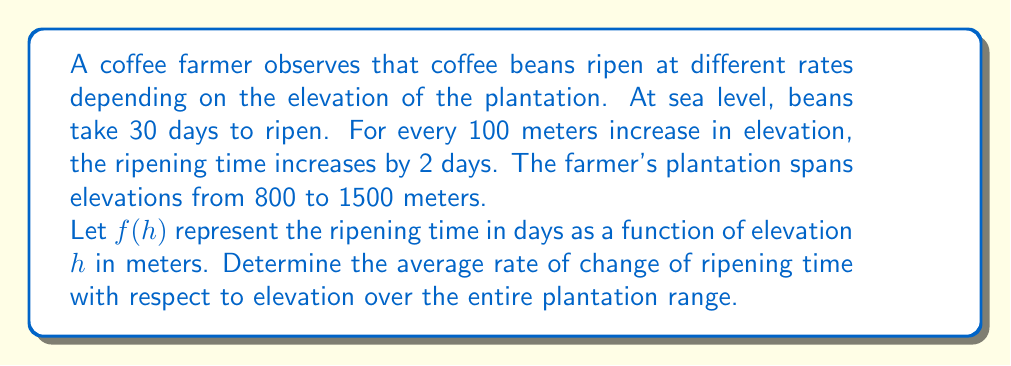Teach me how to tackle this problem. 1) First, let's define the function $f(h)$:
   $f(h) = 30 + 0.02h$, where 30 is the base ripening time and 0.02 is the rate of increase per meter (2 days / 100 meters).

2) To find the average rate of change, we use the formula:
   Average rate of change = $\frac{f(b) - f(a)}{b - a}$
   where $a = 800$ and $b = 1500$ (the elevation range of the plantation)

3) Calculate $f(800)$ and $f(1500)$:
   $f(800) = 30 + 0.02(800) = 46$ days
   $f(1500) = 30 + 0.02(1500) = 60$ days

4) Now, apply the average rate of change formula:
   Average rate of change = $\frac{f(1500) - f(800)}{1500 - 800}$
                          = $\frac{60 - 46}{1500 - 800}$
                          = $\frac{14}{700}$
                          = $0.02$ days/meter

5) This result matches the rate we started with, which is expected for a linear function.
Answer: 0.02 days/meter 